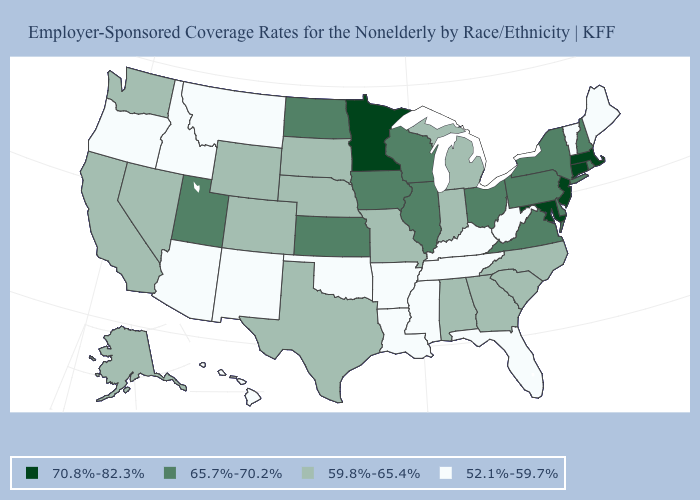What is the value of Oklahoma?
Give a very brief answer. 52.1%-59.7%. What is the value of Tennessee?
Quick response, please. 52.1%-59.7%. What is the value of Massachusetts?
Give a very brief answer. 70.8%-82.3%. Which states hav the highest value in the South?
Keep it brief. Maryland. Name the states that have a value in the range 65.7%-70.2%?
Give a very brief answer. Delaware, Illinois, Iowa, Kansas, New Hampshire, New York, North Dakota, Ohio, Pennsylvania, Rhode Island, Utah, Virginia, Wisconsin. Name the states that have a value in the range 65.7%-70.2%?
Answer briefly. Delaware, Illinois, Iowa, Kansas, New Hampshire, New York, North Dakota, Ohio, Pennsylvania, Rhode Island, Utah, Virginia, Wisconsin. What is the value of Texas?
Answer briefly. 59.8%-65.4%. Which states hav the highest value in the MidWest?
Be succinct. Minnesota. Is the legend a continuous bar?
Quick response, please. No. How many symbols are there in the legend?
Write a very short answer. 4. What is the lowest value in states that border Nebraska?
Concise answer only. 59.8%-65.4%. What is the value of Indiana?
Quick response, please. 59.8%-65.4%. What is the value of California?
Short answer required. 59.8%-65.4%. What is the value of Delaware?
Write a very short answer. 65.7%-70.2%. 